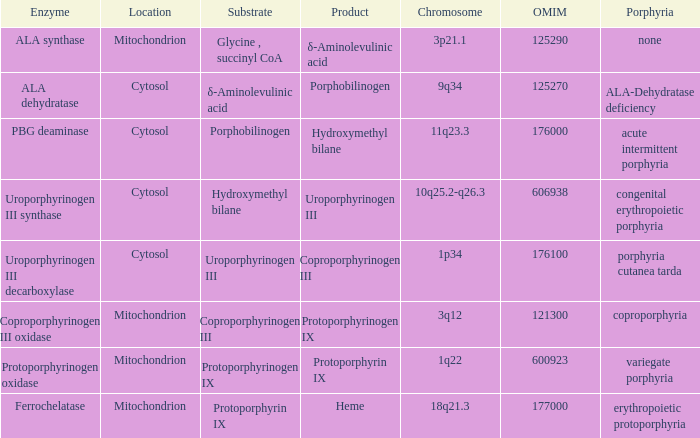Which substrate has an OMIM of 176000? Porphobilinogen. 